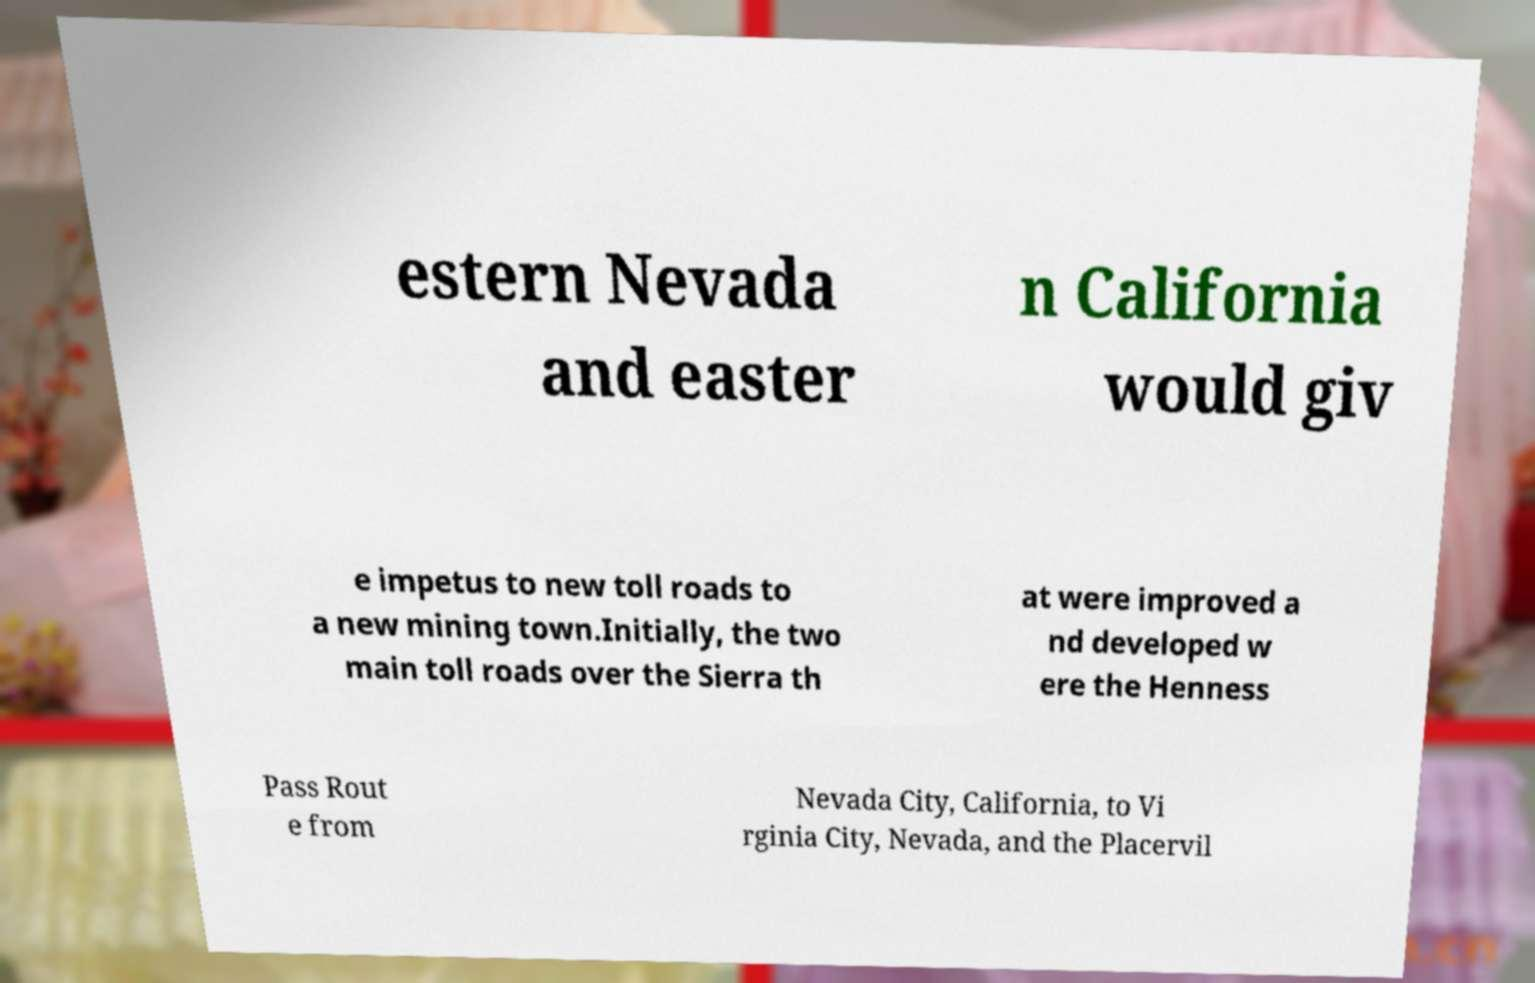What messages or text are displayed in this image? I need them in a readable, typed format. estern Nevada and easter n California would giv e impetus to new toll roads to a new mining town.Initially, the two main toll roads over the Sierra th at were improved a nd developed w ere the Henness Pass Rout e from Nevada City, California, to Vi rginia City, Nevada, and the Placervil 